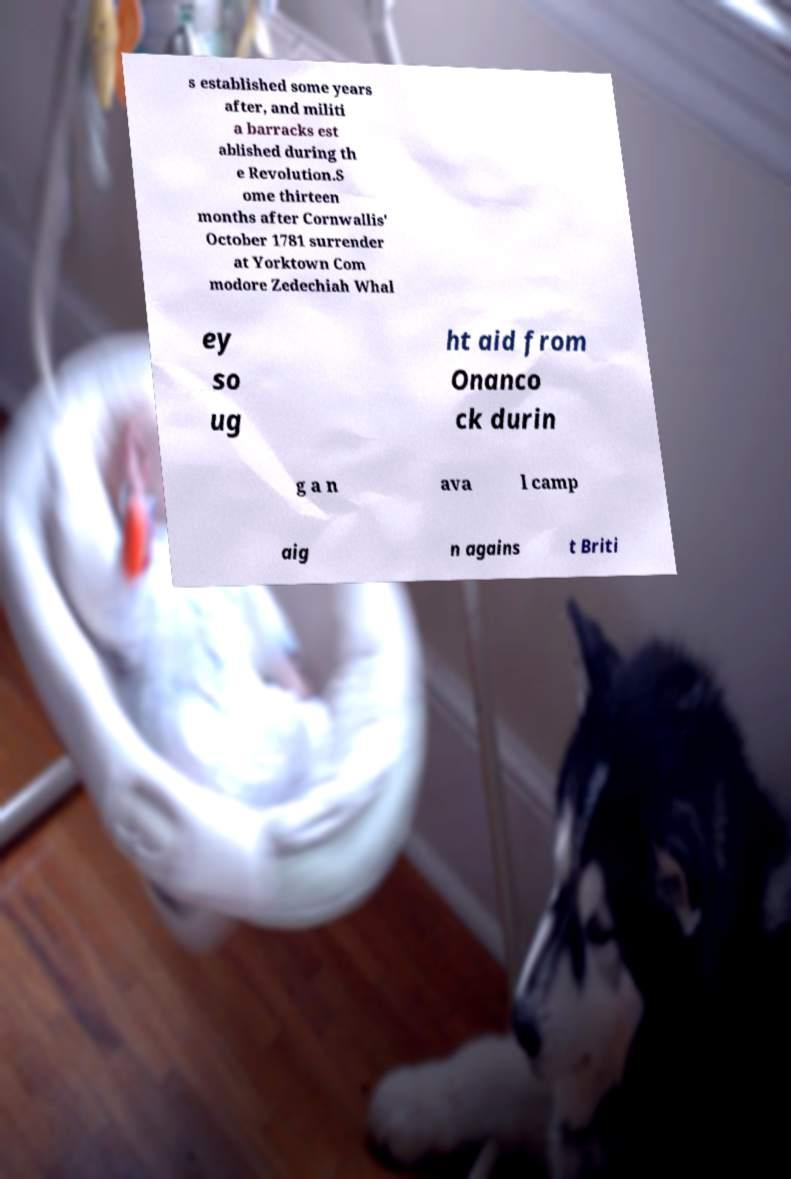Please identify and transcribe the text found in this image. s established some years after, and militi a barracks est ablished during th e Revolution.S ome thirteen months after Cornwallis' October 1781 surrender at Yorktown Com modore Zedechiah Whal ey so ug ht aid from Onanco ck durin g a n ava l camp aig n agains t Briti 